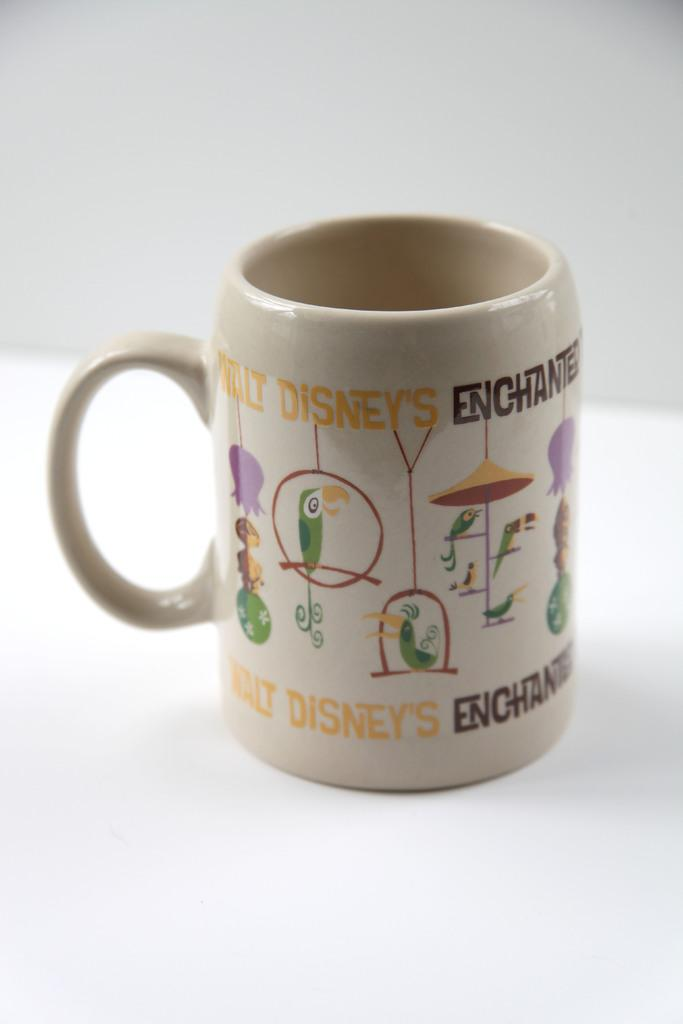<image>
Summarize the visual content of the image. A simple mug with the words Walt Disney's Enchanted printed on it. 